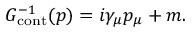<formula> <loc_0><loc_0><loc_500><loc_500>G _ { c o n t } ^ { - 1 } ( p ) = i \gamma _ { \mu } p _ { \mu } + m .</formula> 